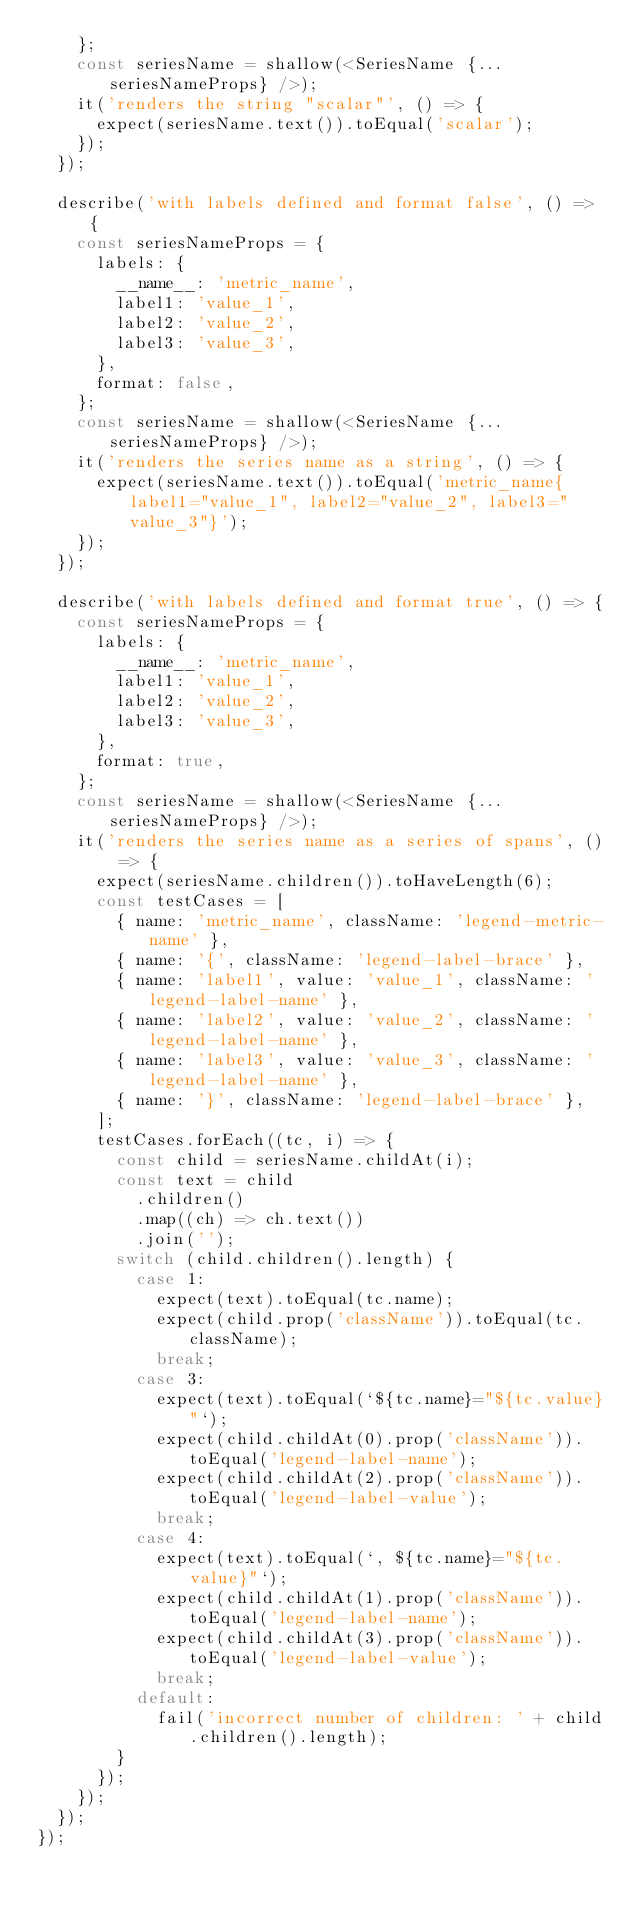<code> <loc_0><loc_0><loc_500><loc_500><_TypeScript_>    };
    const seriesName = shallow(<SeriesName {...seriesNameProps} />);
    it('renders the string "scalar"', () => {
      expect(seriesName.text()).toEqual('scalar');
    });
  });

  describe('with labels defined and format false', () => {
    const seriesNameProps = {
      labels: {
        __name__: 'metric_name',
        label1: 'value_1',
        label2: 'value_2',
        label3: 'value_3',
      },
      format: false,
    };
    const seriesName = shallow(<SeriesName {...seriesNameProps} />);
    it('renders the series name as a string', () => {
      expect(seriesName.text()).toEqual('metric_name{label1="value_1", label2="value_2", label3="value_3"}');
    });
  });

  describe('with labels defined and format true', () => {
    const seriesNameProps = {
      labels: {
        __name__: 'metric_name',
        label1: 'value_1',
        label2: 'value_2',
        label3: 'value_3',
      },
      format: true,
    };
    const seriesName = shallow(<SeriesName {...seriesNameProps} />);
    it('renders the series name as a series of spans', () => {
      expect(seriesName.children()).toHaveLength(6);
      const testCases = [
        { name: 'metric_name', className: 'legend-metric-name' },
        { name: '{', className: 'legend-label-brace' },
        { name: 'label1', value: 'value_1', className: 'legend-label-name' },
        { name: 'label2', value: 'value_2', className: 'legend-label-name' },
        { name: 'label3', value: 'value_3', className: 'legend-label-name' },
        { name: '}', className: 'legend-label-brace' },
      ];
      testCases.forEach((tc, i) => {
        const child = seriesName.childAt(i);
        const text = child
          .children()
          .map((ch) => ch.text())
          .join('');
        switch (child.children().length) {
          case 1:
            expect(text).toEqual(tc.name);
            expect(child.prop('className')).toEqual(tc.className);
            break;
          case 3:
            expect(text).toEqual(`${tc.name}="${tc.value}"`);
            expect(child.childAt(0).prop('className')).toEqual('legend-label-name');
            expect(child.childAt(2).prop('className')).toEqual('legend-label-value');
            break;
          case 4:
            expect(text).toEqual(`, ${tc.name}="${tc.value}"`);
            expect(child.childAt(1).prop('className')).toEqual('legend-label-name');
            expect(child.childAt(3).prop('className')).toEqual('legend-label-value');
            break;
          default:
            fail('incorrect number of children: ' + child.children().length);
        }
      });
    });
  });
});
</code> 